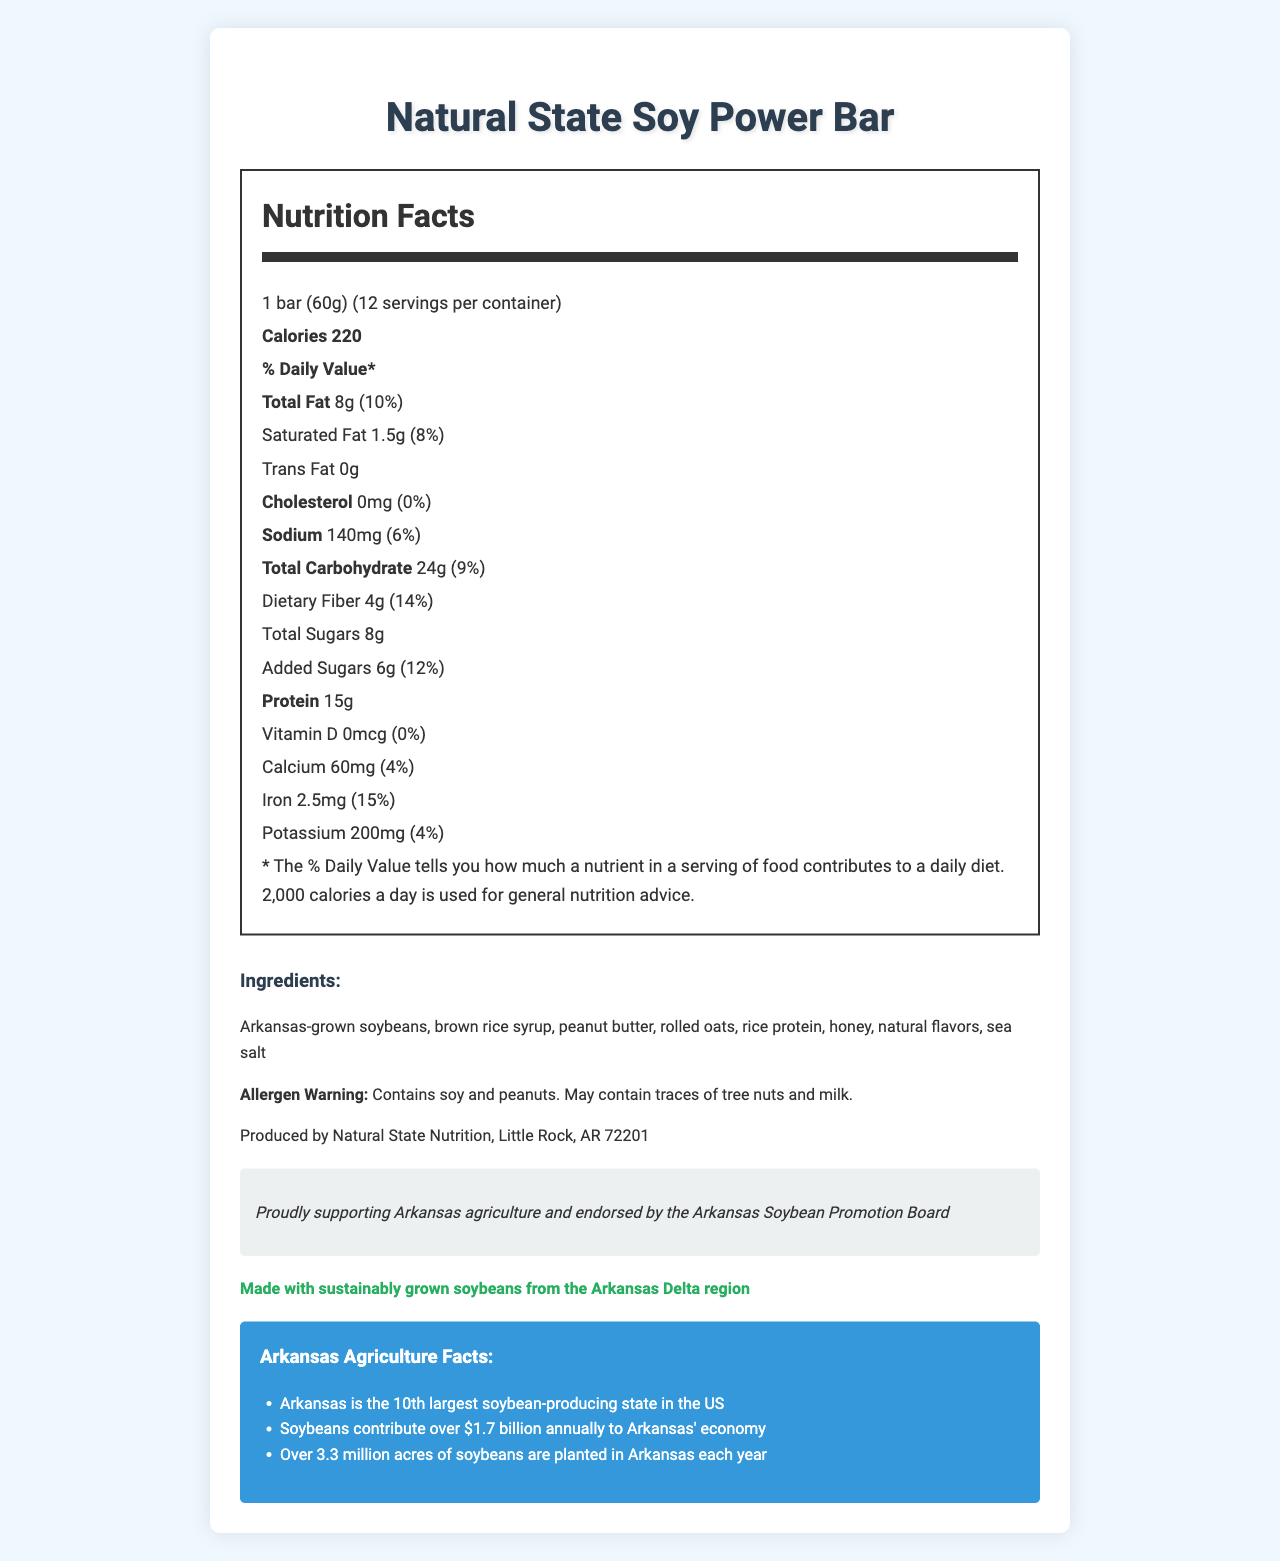who produces the Natural State Soy Power Bar? The document specifies "Produced by Natural State Nutrition, Little Rock, AR 72201" under the manufacturer information section.
Answer: Natural State Nutrition what is the serving size for the Soy Power Bar? The serving size is mentioned as "1 bar (60g)" in the Nutrition Facts section.
Answer: 1 bar (60g) how many grams of protein are in one serving of the protein bar? The Nutrition Facts label lists "15g" next to the protein amount.
Answer: 15g what allergens are present in the Soy Power Bar? The allergen warning states, "Contains soy and peanuts. May contain traces of tree nuts and milk."
Answer: Soy and peanuts which ingredient is highlighted as sustainable? The sustainability note mentions, "Made with sustainably grown soybeans from the Arkansas Delta region."
Answer: Arkansas-grown soybeans how much iron is in one serving of the Soy Power Bar? The amount of iron per serving is listed as 2.5mg with a daily value of 15%.
Answer: 2.5mg how much does one container of Soy Power Bars weigh in total? (choose one) 
1. 600g 
2. 720g 
3. 760g 
4. 780g Each bar weighs 60g, and there are 12 bars per container. Multiplying 60g by 12 gives a total weight of 720g.
Answer: 720g how much dietary fiber is in one serving? 
A. 2g 
B. 4g 
C. 8g 
D. 15g The Nutrition Facts section lists dietary fiber as 4g per serving.
Answer: B is there any cholesterol in the Soy Power Bar? The cholesterol amount is listed as 0mg with a daily value of 0%.
Answer: No summarize the main idea of the document The document gives detailed insights into the nutritional content, ingredient list, and allergen warnings of the Natural State Soy Power Bar, a product endorsed by the Arkansas Soybean Promotion Board. The emphasis is also placed on the sustainability of the soybeans used and the economic significance of the soybean industry in Arkansas.
Answer: The document provides comprehensive nutritional information about the Natural State Soy Power Bar, a protein bar made with Arkansas-grown soybeans. It highlights the bar's ingredients, allergen warnings, and the product's commitment to supporting Arkansas agriculture and sustainability. The label discusses the nutritional value per serving and underscores the contribution of the soybean industry to Arkansas's economy. what year was the Natural State Soy Power Bar first produced? There is no information in the document that specifies when the Natural State Soy Power Bar was first produced.
Answer: Cannot be determined 